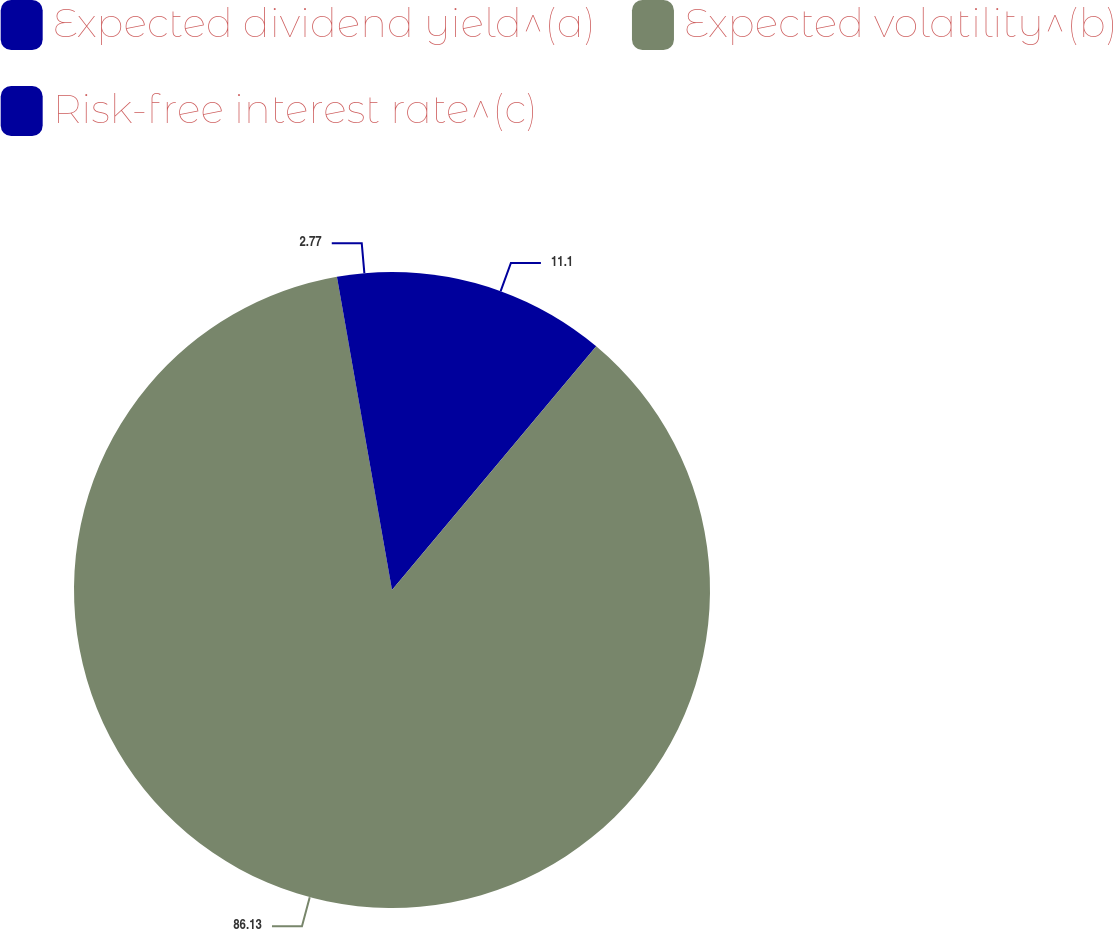Convert chart to OTSL. <chart><loc_0><loc_0><loc_500><loc_500><pie_chart><fcel>Expected dividend yield^(a)<fcel>Expected volatility^(b)<fcel>Risk-free interest rate^(c)<nl><fcel>11.1%<fcel>86.13%<fcel>2.77%<nl></chart> 